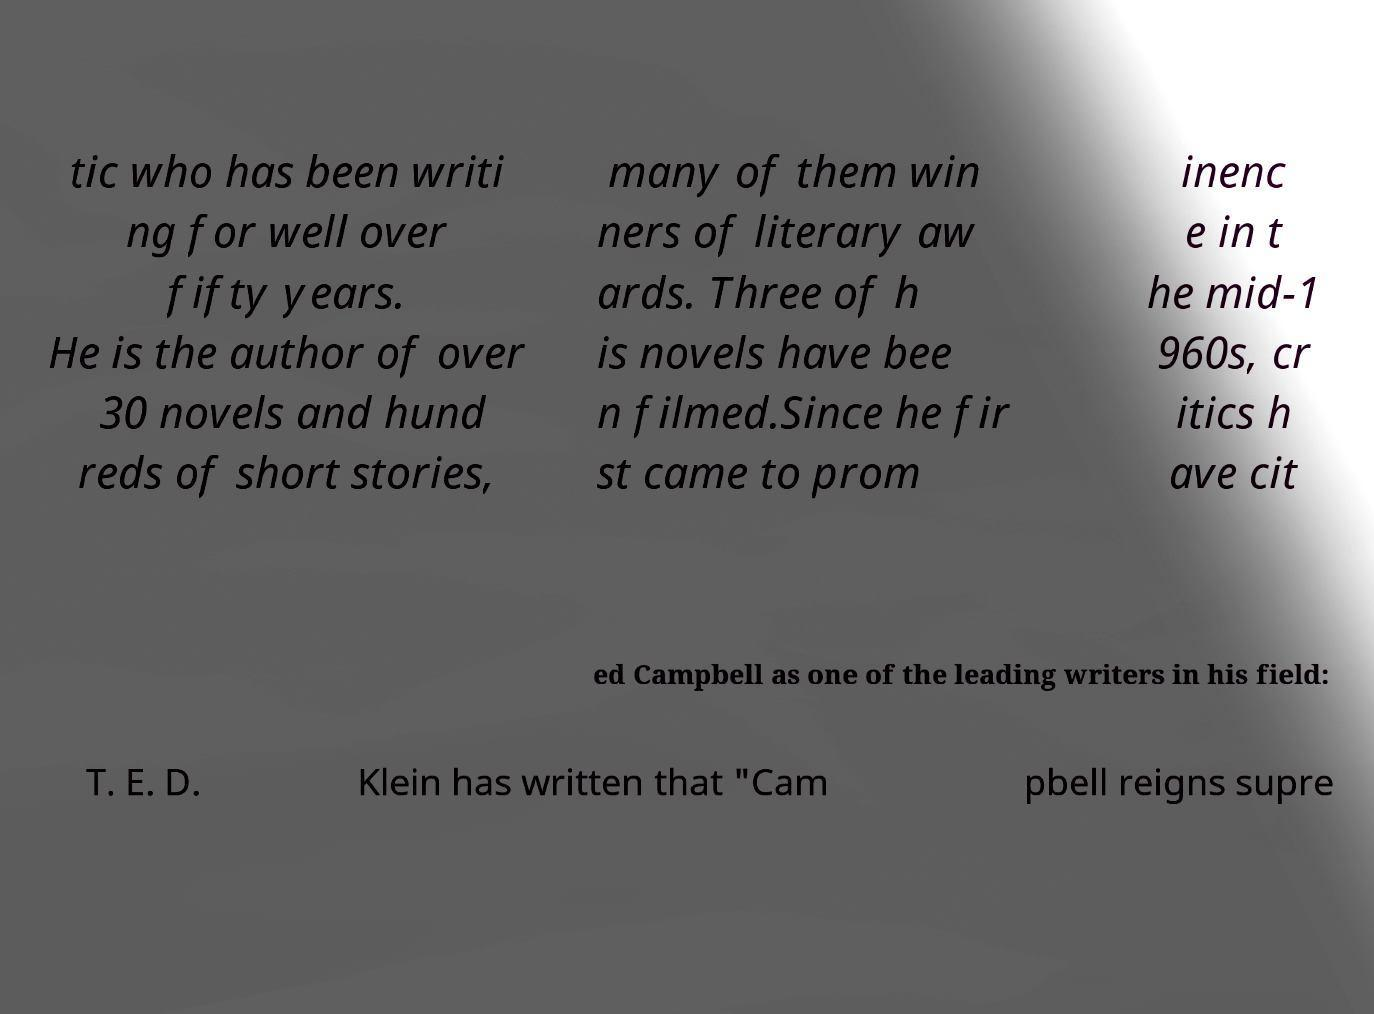For documentation purposes, I need the text within this image transcribed. Could you provide that? tic who has been writi ng for well over fifty years. He is the author of over 30 novels and hund reds of short stories, many of them win ners of literary aw ards. Three of h is novels have bee n filmed.Since he fir st came to prom inenc e in t he mid-1 960s, cr itics h ave cit ed Campbell as one of the leading writers in his field: T. E. D. Klein has written that "Cam pbell reigns supre 